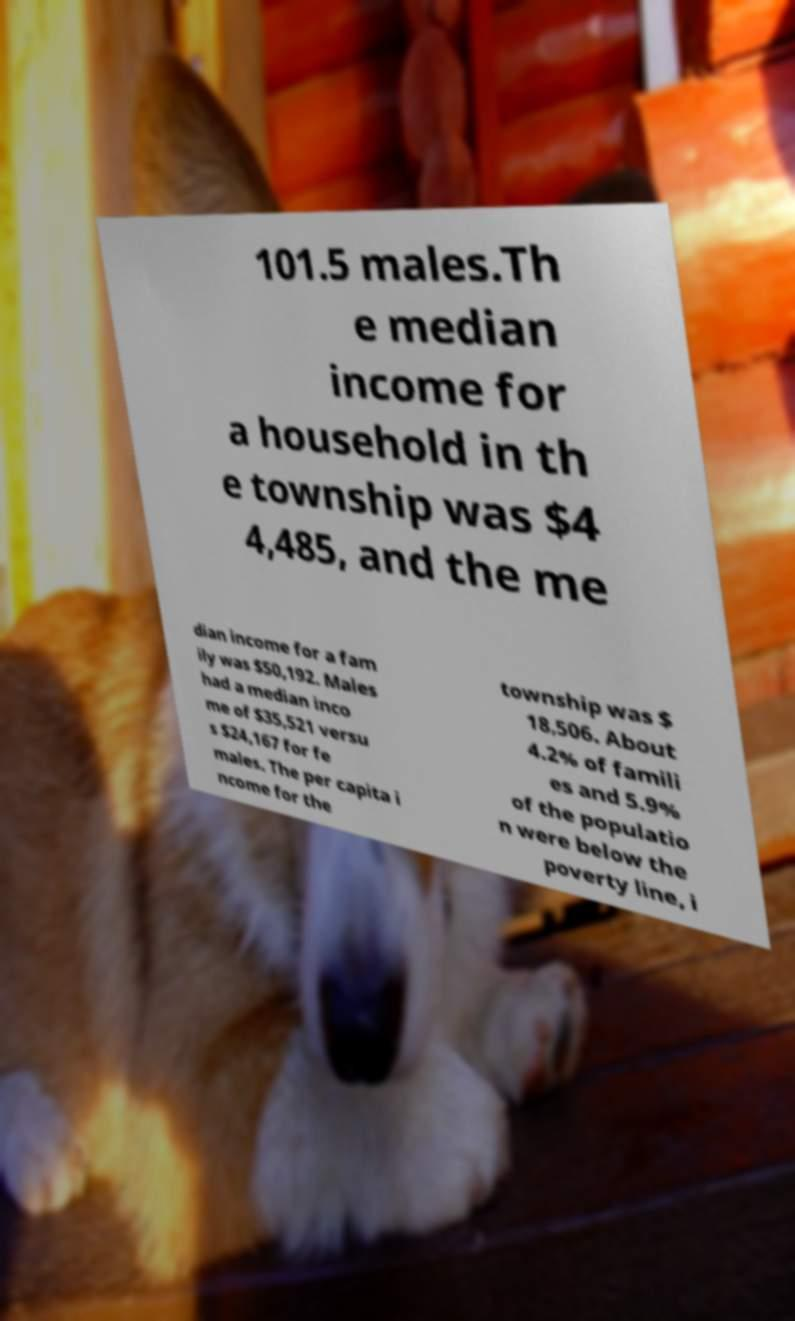Can you read and provide the text displayed in the image?This photo seems to have some interesting text. Can you extract and type it out for me? 101.5 males.Th e median income for a household in th e township was $4 4,485, and the me dian income for a fam ily was $50,192. Males had a median inco me of $35,521 versu s $24,167 for fe males. The per capita i ncome for the township was $ 18,506. About 4.2% of famili es and 5.9% of the populatio n were below the poverty line, i 